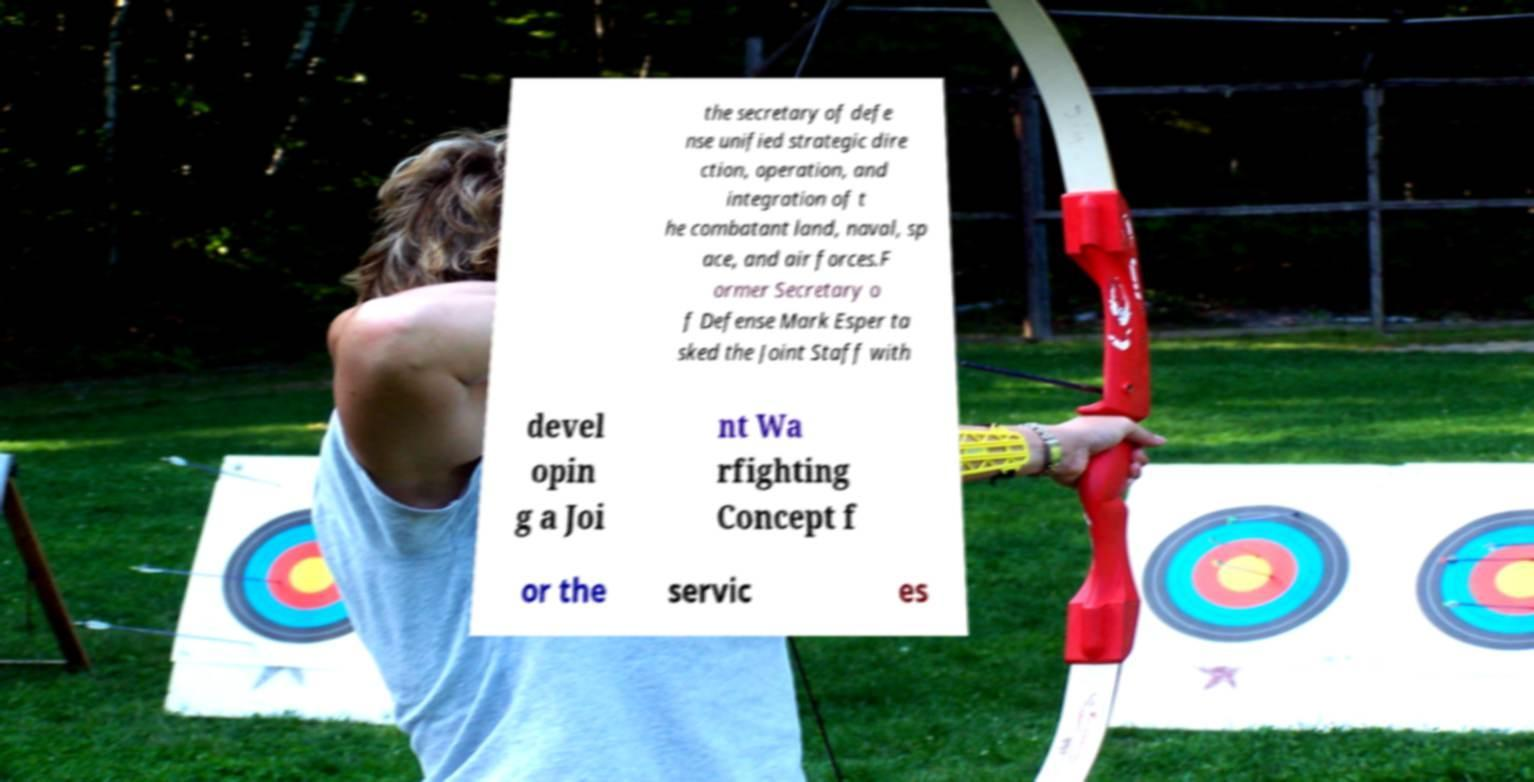Can you accurately transcribe the text from the provided image for me? the secretary of defe nse unified strategic dire ction, operation, and integration of t he combatant land, naval, sp ace, and air forces.F ormer Secretary o f Defense Mark Esper ta sked the Joint Staff with devel opin g a Joi nt Wa rfighting Concept f or the servic es 